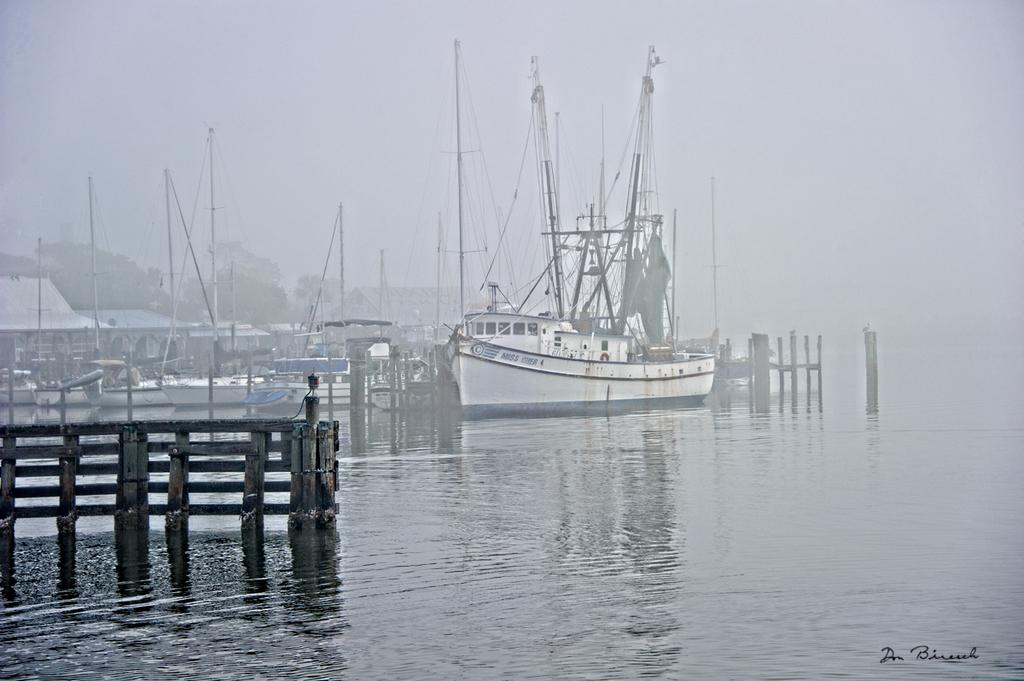What can be seen on the river bank in the image? There are ships on the river bank in the image. What type of barrier is present on the left side of the image? There is a wooden fence on the left side of the image. What is the weather like in the image? The presence of snow in the background suggests that it is cold and possibly snowing. What type of zephyr can be seen blowing through the bottle in the image? There is no bottle or zephyr present in the image. What type of industry is visible in the background of the image? There is no industry visible in the image; it primarily features ships, a wooden fence, and snow. 